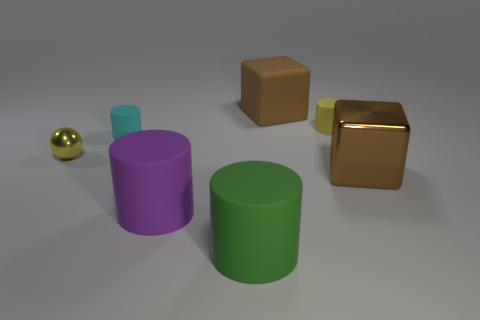What material is the tiny ball?
Offer a very short reply. Metal. What number of other objects are the same material as the small yellow sphere?
Ensure brevity in your answer.  1. There is a cylinder that is on the right side of the purple rubber object and behind the large shiny block; what size is it?
Keep it short and to the point. Small. There is a small yellow thing that is in front of the small rubber object right of the small cyan cylinder; what is its shape?
Your response must be concise. Sphere. Is there any other thing that has the same shape as the tiny metal object?
Your response must be concise. No. Are there an equal number of large purple cylinders behind the matte cube and yellow metal balls?
Ensure brevity in your answer.  No. Is the color of the matte cube the same as the large cube that is in front of the tiny metal sphere?
Give a very brief answer. Yes. The rubber thing that is both on the left side of the yellow cylinder and behind the cyan rubber object is what color?
Ensure brevity in your answer.  Brown. What number of small metal balls are on the right side of the tiny yellow thing that is right of the cyan matte cylinder?
Your answer should be very brief. 0. Is there a large red metallic thing of the same shape as the big green thing?
Your response must be concise. No. 